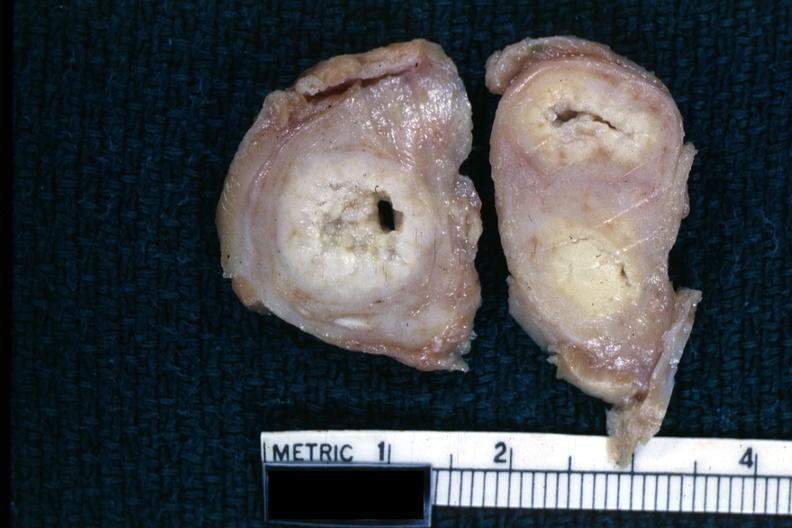s adrenal of premature 30 week gestation gram infant lesion present?
Answer the question using a single word or phrase. No 